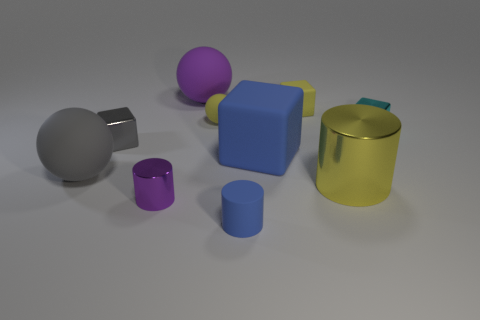Are there an equal number of blue matte objects behind the tiny purple metal cylinder and large blue rubber things?
Offer a very short reply. Yes. What number of other things are there of the same shape as the tiny cyan thing?
Your answer should be compact. 3. There is a big purple ball; what number of gray cubes are behind it?
Provide a short and direct response. 0. There is a cylinder that is on the right side of the tiny rubber ball and to the left of the large metal cylinder; how big is it?
Ensure brevity in your answer.  Small. Are any brown cylinders visible?
Ensure brevity in your answer.  No. How many other objects are there of the same size as the gray shiny cube?
Offer a terse response. 5. Do the large matte sphere behind the small yellow matte sphere and the small shiny thing in front of the large blue matte thing have the same color?
Your answer should be compact. Yes. What is the size of the blue rubber object that is the same shape as the small cyan thing?
Provide a succinct answer. Large. Do the sphere that is in front of the small yellow ball and the big purple ball on the left side of the tiny cyan metal thing have the same material?
Your answer should be very brief. Yes. How many metallic things are yellow balls or big yellow objects?
Ensure brevity in your answer.  1. 